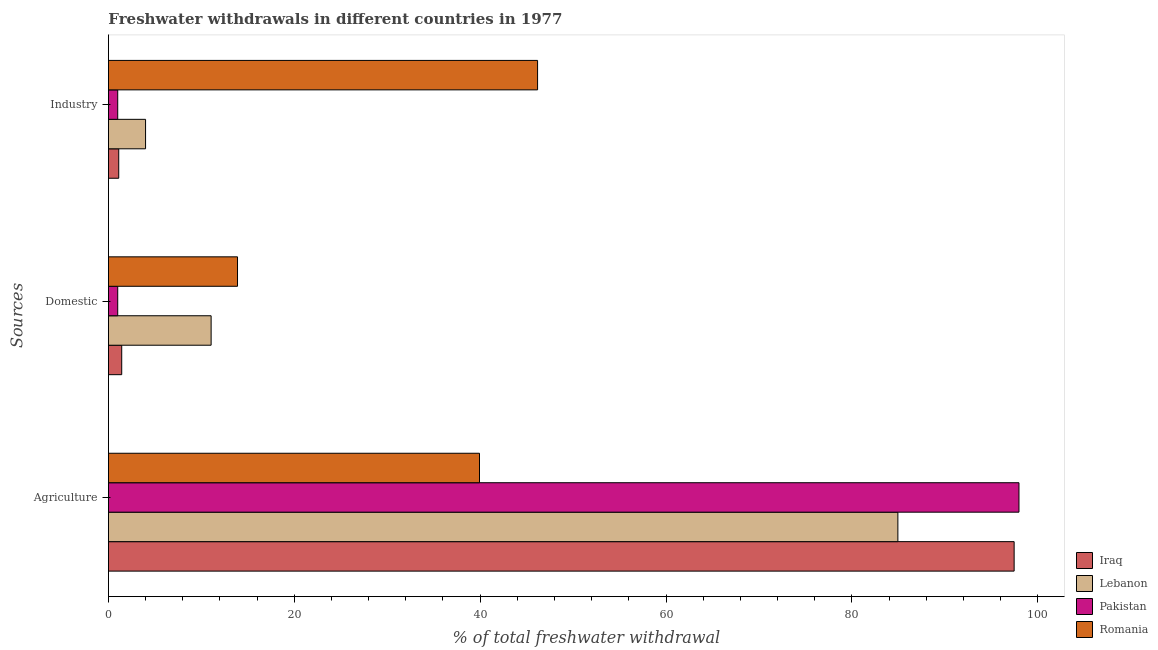How many different coloured bars are there?
Give a very brief answer. 4. How many groups of bars are there?
Make the answer very short. 3. How many bars are there on the 3rd tick from the bottom?
Offer a terse response. 4. What is the label of the 2nd group of bars from the top?
Keep it short and to the point. Domestic. What is the percentage of freshwater withdrawal for domestic purposes in Romania?
Your answer should be compact. 13.89. Across all countries, what is the maximum percentage of freshwater withdrawal for industry?
Offer a terse response. 46.18. Across all countries, what is the minimum percentage of freshwater withdrawal for agriculture?
Provide a short and direct response. 39.93. In which country was the percentage of freshwater withdrawal for industry maximum?
Make the answer very short. Romania. In which country was the percentage of freshwater withdrawal for agriculture minimum?
Keep it short and to the point. Romania. What is the total percentage of freshwater withdrawal for industry in the graph?
Keep it short and to the point. 52.28. What is the difference between the percentage of freshwater withdrawal for agriculture in Iraq and that in Romania?
Offer a very short reply. 57.53. What is the difference between the percentage of freshwater withdrawal for industry in Lebanon and the percentage of freshwater withdrawal for agriculture in Pakistan?
Give a very brief answer. -93.98. What is the average percentage of freshwater withdrawal for agriculture per country?
Your answer should be very brief. 80.08. What is the difference between the percentage of freshwater withdrawal for agriculture and percentage of freshwater withdrawal for domestic purposes in Lebanon?
Your answer should be very brief. 73.9. What is the ratio of the percentage of freshwater withdrawal for domestic purposes in Iraq to that in Romania?
Your answer should be very brief. 0.1. What is the difference between the highest and the second highest percentage of freshwater withdrawal for agriculture?
Give a very brief answer. 0.52. What is the difference between the highest and the lowest percentage of freshwater withdrawal for industry?
Your answer should be compact. 45.18. Is the sum of the percentage of freshwater withdrawal for agriculture in Lebanon and Pakistan greater than the maximum percentage of freshwater withdrawal for domestic purposes across all countries?
Offer a very short reply. Yes. What does the 4th bar from the top in Agriculture represents?
Provide a short and direct response. Iraq. What does the 4th bar from the bottom in Domestic represents?
Ensure brevity in your answer.  Romania. How many bars are there?
Make the answer very short. 12. How many countries are there in the graph?
Your answer should be compact. 4. Does the graph contain grids?
Your answer should be compact. No. How are the legend labels stacked?
Make the answer very short. Vertical. What is the title of the graph?
Your response must be concise. Freshwater withdrawals in different countries in 1977. What is the label or title of the X-axis?
Provide a succinct answer. % of total freshwater withdrawal. What is the label or title of the Y-axis?
Make the answer very short. Sources. What is the % of total freshwater withdrawal of Iraq in Agriculture?
Offer a very short reply. 97.46. What is the % of total freshwater withdrawal in Lebanon in Agriculture?
Make the answer very short. 84.95. What is the % of total freshwater withdrawal of Pakistan in Agriculture?
Your response must be concise. 97.98. What is the % of total freshwater withdrawal in Romania in Agriculture?
Provide a succinct answer. 39.93. What is the % of total freshwater withdrawal of Iraq in Domestic?
Your response must be concise. 1.43. What is the % of total freshwater withdrawal of Lebanon in Domestic?
Offer a very short reply. 11.05. What is the % of total freshwater withdrawal of Pakistan in Domestic?
Ensure brevity in your answer.  1. What is the % of total freshwater withdrawal in Romania in Domestic?
Offer a terse response. 13.89. What is the % of total freshwater withdrawal in Iraq in Industry?
Provide a short and direct response. 1.11. What is the % of total freshwater withdrawal in Lebanon in Industry?
Make the answer very short. 4. What is the % of total freshwater withdrawal in Pakistan in Industry?
Your answer should be very brief. 1. What is the % of total freshwater withdrawal in Romania in Industry?
Provide a short and direct response. 46.18. Across all Sources, what is the maximum % of total freshwater withdrawal in Iraq?
Provide a short and direct response. 97.46. Across all Sources, what is the maximum % of total freshwater withdrawal in Lebanon?
Your answer should be compact. 84.95. Across all Sources, what is the maximum % of total freshwater withdrawal in Pakistan?
Keep it short and to the point. 97.98. Across all Sources, what is the maximum % of total freshwater withdrawal in Romania?
Make the answer very short. 46.18. Across all Sources, what is the minimum % of total freshwater withdrawal in Iraq?
Provide a succinct answer. 1.11. Across all Sources, what is the minimum % of total freshwater withdrawal of Lebanon?
Offer a terse response. 4. Across all Sources, what is the minimum % of total freshwater withdrawal of Romania?
Ensure brevity in your answer.  13.89. What is the total % of total freshwater withdrawal in Iraq in the graph?
Offer a terse response. 100. What is the total % of total freshwater withdrawal in Lebanon in the graph?
Keep it short and to the point. 100. What is the total % of total freshwater withdrawal of Pakistan in the graph?
Give a very brief answer. 99.98. What is the difference between the % of total freshwater withdrawal in Iraq in Agriculture and that in Domestic?
Ensure brevity in your answer.  96.03. What is the difference between the % of total freshwater withdrawal in Lebanon in Agriculture and that in Domestic?
Offer a terse response. 73.9. What is the difference between the % of total freshwater withdrawal of Pakistan in Agriculture and that in Domestic?
Offer a very short reply. 96.98. What is the difference between the % of total freshwater withdrawal of Romania in Agriculture and that in Domestic?
Offer a terse response. 26.04. What is the difference between the % of total freshwater withdrawal of Iraq in Agriculture and that in Industry?
Provide a succinct answer. 96.35. What is the difference between the % of total freshwater withdrawal in Lebanon in Agriculture and that in Industry?
Offer a terse response. 80.95. What is the difference between the % of total freshwater withdrawal in Pakistan in Agriculture and that in Industry?
Offer a terse response. 96.98. What is the difference between the % of total freshwater withdrawal in Romania in Agriculture and that in Industry?
Offer a very short reply. -6.25. What is the difference between the % of total freshwater withdrawal in Iraq in Domestic and that in Industry?
Offer a very short reply. 0.32. What is the difference between the % of total freshwater withdrawal in Lebanon in Domestic and that in Industry?
Provide a short and direct response. 7.05. What is the difference between the % of total freshwater withdrawal in Romania in Domestic and that in Industry?
Keep it short and to the point. -32.29. What is the difference between the % of total freshwater withdrawal of Iraq in Agriculture and the % of total freshwater withdrawal of Lebanon in Domestic?
Provide a succinct answer. 86.41. What is the difference between the % of total freshwater withdrawal in Iraq in Agriculture and the % of total freshwater withdrawal in Pakistan in Domestic?
Ensure brevity in your answer.  96.46. What is the difference between the % of total freshwater withdrawal of Iraq in Agriculture and the % of total freshwater withdrawal of Romania in Domestic?
Your answer should be compact. 83.57. What is the difference between the % of total freshwater withdrawal of Lebanon in Agriculture and the % of total freshwater withdrawal of Pakistan in Domestic?
Your answer should be very brief. 83.95. What is the difference between the % of total freshwater withdrawal of Lebanon in Agriculture and the % of total freshwater withdrawal of Romania in Domestic?
Give a very brief answer. 71.06. What is the difference between the % of total freshwater withdrawal in Pakistan in Agriculture and the % of total freshwater withdrawal in Romania in Domestic?
Your answer should be compact. 84.09. What is the difference between the % of total freshwater withdrawal of Iraq in Agriculture and the % of total freshwater withdrawal of Lebanon in Industry?
Your answer should be very brief. 93.47. What is the difference between the % of total freshwater withdrawal of Iraq in Agriculture and the % of total freshwater withdrawal of Pakistan in Industry?
Offer a terse response. 96.46. What is the difference between the % of total freshwater withdrawal of Iraq in Agriculture and the % of total freshwater withdrawal of Romania in Industry?
Provide a succinct answer. 51.28. What is the difference between the % of total freshwater withdrawal in Lebanon in Agriculture and the % of total freshwater withdrawal in Pakistan in Industry?
Your answer should be very brief. 83.95. What is the difference between the % of total freshwater withdrawal of Lebanon in Agriculture and the % of total freshwater withdrawal of Romania in Industry?
Provide a short and direct response. 38.77. What is the difference between the % of total freshwater withdrawal in Pakistan in Agriculture and the % of total freshwater withdrawal in Romania in Industry?
Offer a terse response. 51.8. What is the difference between the % of total freshwater withdrawal of Iraq in Domestic and the % of total freshwater withdrawal of Lebanon in Industry?
Offer a terse response. -2.56. What is the difference between the % of total freshwater withdrawal in Iraq in Domestic and the % of total freshwater withdrawal in Pakistan in Industry?
Offer a very short reply. 0.43. What is the difference between the % of total freshwater withdrawal in Iraq in Domestic and the % of total freshwater withdrawal in Romania in Industry?
Your response must be concise. -44.75. What is the difference between the % of total freshwater withdrawal of Lebanon in Domestic and the % of total freshwater withdrawal of Pakistan in Industry?
Offer a terse response. 10.05. What is the difference between the % of total freshwater withdrawal of Lebanon in Domestic and the % of total freshwater withdrawal of Romania in Industry?
Offer a very short reply. -35.13. What is the difference between the % of total freshwater withdrawal in Pakistan in Domestic and the % of total freshwater withdrawal in Romania in Industry?
Give a very brief answer. -45.18. What is the average % of total freshwater withdrawal in Iraq per Sources?
Your answer should be compact. 33.33. What is the average % of total freshwater withdrawal of Lebanon per Sources?
Keep it short and to the point. 33.33. What is the average % of total freshwater withdrawal in Pakistan per Sources?
Keep it short and to the point. 33.33. What is the average % of total freshwater withdrawal in Romania per Sources?
Your answer should be compact. 33.33. What is the difference between the % of total freshwater withdrawal in Iraq and % of total freshwater withdrawal in Lebanon in Agriculture?
Keep it short and to the point. 12.51. What is the difference between the % of total freshwater withdrawal in Iraq and % of total freshwater withdrawal in Pakistan in Agriculture?
Offer a very short reply. -0.52. What is the difference between the % of total freshwater withdrawal of Iraq and % of total freshwater withdrawal of Romania in Agriculture?
Make the answer very short. 57.53. What is the difference between the % of total freshwater withdrawal in Lebanon and % of total freshwater withdrawal in Pakistan in Agriculture?
Offer a terse response. -13.03. What is the difference between the % of total freshwater withdrawal in Lebanon and % of total freshwater withdrawal in Romania in Agriculture?
Offer a very short reply. 45.02. What is the difference between the % of total freshwater withdrawal in Pakistan and % of total freshwater withdrawal in Romania in Agriculture?
Your answer should be compact. 58.05. What is the difference between the % of total freshwater withdrawal of Iraq and % of total freshwater withdrawal of Lebanon in Domestic?
Keep it short and to the point. -9.62. What is the difference between the % of total freshwater withdrawal in Iraq and % of total freshwater withdrawal in Pakistan in Domestic?
Keep it short and to the point. 0.43. What is the difference between the % of total freshwater withdrawal of Iraq and % of total freshwater withdrawal of Romania in Domestic?
Give a very brief answer. -12.46. What is the difference between the % of total freshwater withdrawal in Lebanon and % of total freshwater withdrawal in Pakistan in Domestic?
Provide a short and direct response. 10.05. What is the difference between the % of total freshwater withdrawal of Lebanon and % of total freshwater withdrawal of Romania in Domestic?
Keep it short and to the point. -2.84. What is the difference between the % of total freshwater withdrawal of Pakistan and % of total freshwater withdrawal of Romania in Domestic?
Keep it short and to the point. -12.89. What is the difference between the % of total freshwater withdrawal in Iraq and % of total freshwater withdrawal in Lebanon in Industry?
Give a very brief answer. -2.89. What is the difference between the % of total freshwater withdrawal in Iraq and % of total freshwater withdrawal in Pakistan in Industry?
Ensure brevity in your answer.  0.11. What is the difference between the % of total freshwater withdrawal in Iraq and % of total freshwater withdrawal in Romania in Industry?
Provide a short and direct response. -45.07. What is the difference between the % of total freshwater withdrawal in Lebanon and % of total freshwater withdrawal in Pakistan in Industry?
Your answer should be very brief. 3. What is the difference between the % of total freshwater withdrawal in Lebanon and % of total freshwater withdrawal in Romania in Industry?
Make the answer very short. -42.19. What is the difference between the % of total freshwater withdrawal in Pakistan and % of total freshwater withdrawal in Romania in Industry?
Provide a short and direct response. -45.18. What is the ratio of the % of total freshwater withdrawal of Iraq in Agriculture to that in Domestic?
Make the answer very short. 68.15. What is the ratio of the % of total freshwater withdrawal of Lebanon in Agriculture to that in Domestic?
Your response must be concise. 7.69. What is the ratio of the % of total freshwater withdrawal in Pakistan in Agriculture to that in Domestic?
Your answer should be very brief. 97.98. What is the ratio of the % of total freshwater withdrawal in Romania in Agriculture to that in Domestic?
Ensure brevity in your answer.  2.87. What is the ratio of the % of total freshwater withdrawal of Iraq in Agriculture to that in Industry?
Your answer should be compact. 87.88. What is the ratio of the % of total freshwater withdrawal in Lebanon in Agriculture to that in Industry?
Give a very brief answer. 21.26. What is the ratio of the % of total freshwater withdrawal in Pakistan in Agriculture to that in Industry?
Offer a terse response. 97.98. What is the ratio of the % of total freshwater withdrawal of Romania in Agriculture to that in Industry?
Provide a succinct answer. 0.86. What is the ratio of the % of total freshwater withdrawal of Iraq in Domestic to that in Industry?
Give a very brief answer. 1.29. What is the ratio of the % of total freshwater withdrawal of Lebanon in Domestic to that in Industry?
Your answer should be very brief. 2.77. What is the ratio of the % of total freshwater withdrawal in Pakistan in Domestic to that in Industry?
Make the answer very short. 1. What is the ratio of the % of total freshwater withdrawal in Romania in Domestic to that in Industry?
Your answer should be very brief. 0.3. What is the difference between the highest and the second highest % of total freshwater withdrawal in Iraq?
Give a very brief answer. 96.03. What is the difference between the highest and the second highest % of total freshwater withdrawal in Lebanon?
Make the answer very short. 73.9. What is the difference between the highest and the second highest % of total freshwater withdrawal in Pakistan?
Make the answer very short. 96.98. What is the difference between the highest and the second highest % of total freshwater withdrawal in Romania?
Ensure brevity in your answer.  6.25. What is the difference between the highest and the lowest % of total freshwater withdrawal of Iraq?
Keep it short and to the point. 96.35. What is the difference between the highest and the lowest % of total freshwater withdrawal of Lebanon?
Offer a terse response. 80.95. What is the difference between the highest and the lowest % of total freshwater withdrawal of Pakistan?
Provide a short and direct response. 96.98. What is the difference between the highest and the lowest % of total freshwater withdrawal in Romania?
Your answer should be very brief. 32.29. 